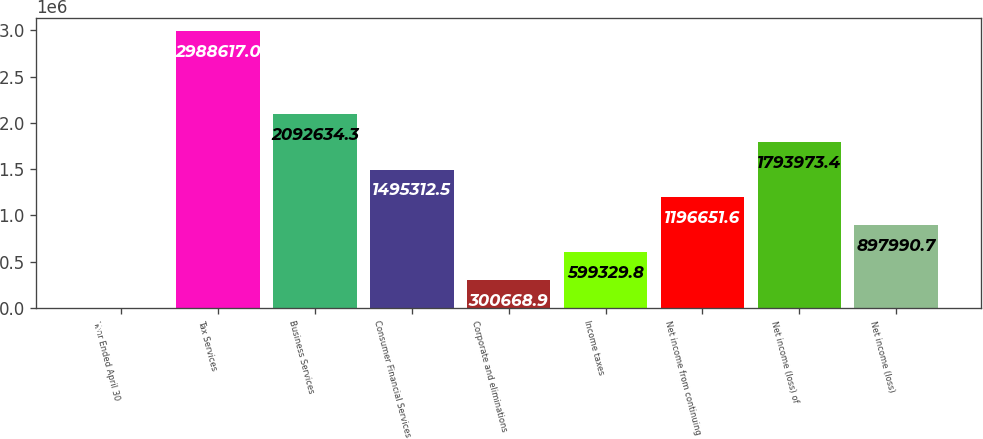<chart> <loc_0><loc_0><loc_500><loc_500><bar_chart><fcel>Year Ended April 30<fcel>Tax Services<fcel>Business Services<fcel>Consumer Financial Services<fcel>Corporate and eliminations<fcel>Income taxes<fcel>Net income from continuing<fcel>Net income (loss) of<fcel>Net income (loss)<nl><fcel>2008<fcel>2.98862e+06<fcel>2.09263e+06<fcel>1.49531e+06<fcel>300669<fcel>599330<fcel>1.19665e+06<fcel>1.79397e+06<fcel>897991<nl></chart> 